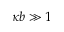<formula> <loc_0><loc_0><loc_500><loc_500>\kappa b \gg 1</formula> 